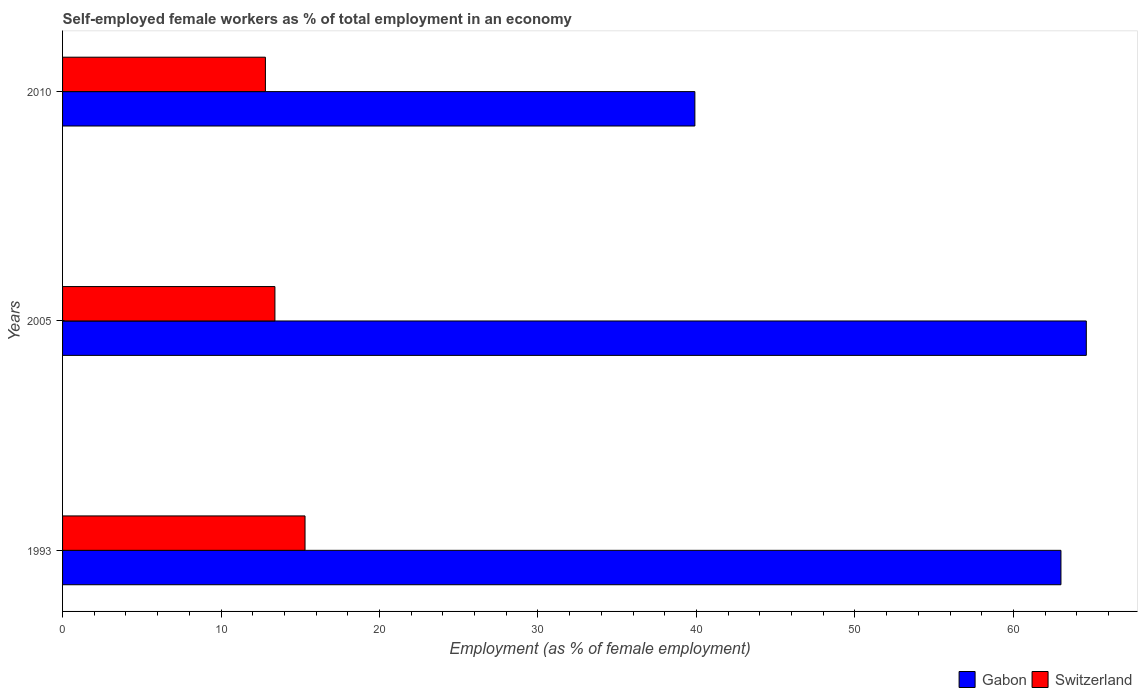How many different coloured bars are there?
Offer a very short reply. 2. How many groups of bars are there?
Provide a succinct answer. 3. Are the number of bars per tick equal to the number of legend labels?
Offer a terse response. Yes. What is the percentage of self-employed female workers in Switzerland in 1993?
Ensure brevity in your answer.  15.3. Across all years, what is the maximum percentage of self-employed female workers in Switzerland?
Keep it short and to the point. 15.3. Across all years, what is the minimum percentage of self-employed female workers in Gabon?
Make the answer very short. 39.9. In which year was the percentage of self-employed female workers in Gabon maximum?
Offer a terse response. 2005. In which year was the percentage of self-employed female workers in Gabon minimum?
Your answer should be compact. 2010. What is the total percentage of self-employed female workers in Gabon in the graph?
Provide a succinct answer. 167.5. What is the difference between the percentage of self-employed female workers in Switzerland in 1993 and that in 2005?
Your answer should be very brief. 1.9. What is the difference between the percentage of self-employed female workers in Gabon in 2010 and the percentage of self-employed female workers in Switzerland in 1993?
Give a very brief answer. 24.6. What is the average percentage of self-employed female workers in Gabon per year?
Your answer should be compact. 55.83. In the year 2010, what is the difference between the percentage of self-employed female workers in Switzerland and percentage of self-employed female workers in Gabon?
Provide a short and direct response. -27.1. What is the ratio of the percentage of self-employed female workers in Switzerland in 1993 to that in 2005?
Provide a succinct answer. 1.14. Is the percentage of self-employed female workers in Switzerland in 1993 less than that in 2010?
Ensure brevity in your answer.  No. Is the difference between the percentage of self-employed female workers in Switzerland in 1993 and 2005 greater than the difference between the percentage of self-employed female workers in Gabon in 1993 and 2005?
Offer a terse response. Yes. What is the difference between the highest and the second highest percentage of self-employed female workers in Switzerland?
Offer a very short reply. 1.9. In how many years, is the percentage of self-employed female workers in Switzerland greater than the average percentage of self-employed female workers in Switzerland taken over all years?
Provide a short and direct response. 1. What does the 1st bar from the top in 2010 represents?
Give a very brief answer. Switzerland. What does the 2nd bar from the bottom in 2005 represents?
Provide a short and direct response. Switzerland. Are all the bars in the graph horizontal?
Make the answer very short. Yes. How many years are there in the graph?
Offer a terse response. 3. What is the difference between two consecutive major ticks on the X-axis?
Your answer should be compact. 10. Are the values on the major ticks of X-axis written in scientific E-notation?
Your answer should be compact. No. Does the graph contain any zero values?
Your answer should be compact. No. Does the graph contain grids?
Keep it short and to the point. No. How many legend labels are there?
Provide a succinct answer. 2. What is the title of the graph?
Your response must be concise. Self-employed female workers as % of total employment in an economy. What is the label or title of the X-axis?
Your answer should be very brief. Employment (as % of female employment). What is the label or title of the Y-axis?
Offer a terse response. Years. What is the Employment (as % of female employment) in Switzerland in 1993?
Your answer should be very brief. 15.3. What is the Employment (as % of female employment) in Gabon in 2005?
Your answer should be very brief. 64.6. What is the Employment (as % of female employment) of Switzerland in 2005?
Keep it short and to the point. 13.4. What is the Employment (as % of female employment) in Gabon in 2010?
Make the answer very short. 39.9. What is the Employment (as % of female employment) in Switzerland in 2010?
Offer a terse response. 12.8. Across all years, what is the maximum Employment (as % of female employment) of Gabon?
Offer a very short reply. 64.6. Across all years, what is the maximum Employment (as % of female employment) of Switzerland?
Offer a very short reply. 15.3. Across all years, what is the minimum Employment (as % of female employment) in Gabon?
Give a very brief answer. 39.9. Across all years, what is the minimum Employment (as % of female employment) in Switzerland?
Make the answer very short. 12.8. What is the total Employment (as % of female employment) of Gabon in the graph?
Your answer should be compact. 167.5. What is the total Employment (as % of female employment) in Switzerland in the graph?
Your response must be concise. 41.5. What is the difference between the Employment (as % of female employment) in Gabon in 1993 and that in 2005?
Your response must be concise. -1.6. What is the difference between the Employment (as % of female employment) of Switzerland in 1993 and that in 2005?
Your answer should be compact. 1.9. What is the difference between the Employment (as % of female employment) of Gabon in 1993 and that in 2010?
Give a very brief answer. 23.1. What is the difference between the Employment (as % of female employment) in Gabon in 2005 and that in 2010?
Provide a short and direct response. 24.7. What is the difference between the Employment (as % of female employment) in Switzerland in 2005 and that in 2010?
Your answer should be compact. 0.6. What is the difference between the Employment (as % of female employment) of Gabon in 1993 and the Employment (as % of female employment) of Switzerland in 2005?
Make the answer very short. 49.6. What is the difference between the Employment (as % of female employment) of Gabon in 1993 and the Employment (as % of female employment) of Switzerland in 2010?
Make the answer very short. 50.2. What is the difference between the Employment (as % of female employment) in Gabon in 2005 and the Employment (as % of female employment) in Switzerland in 2010?
Your answer should be very brief. 51.8. What is the average Employment (as % of female employment) in Gabon per year?
Your answer should be compact. 55.83. What is the average Employment (as % of female employment) of Switzerland per year?
Provide a short and direct response. 13.83. In the year 1993, what is the difference between the Employment (as % of female employment) of Gabon and Employment (as % of female employment) of Switzerland?
Give a very brief answer. 47.7. In the year 2005, what is the difference between the Employment (as % of female employment) of Gabon and Employment (as % of female employment) of Switzerland?
Offer a very short reply. 51.2. In the year 2010, what is the difference between the Employment (as % of female employment) of Gabon and Employment (as % of female employment) of Switzerland?
Provide a short and direct response. 27.1. What is the ratio of the Employment (as % of female employment) in Gabon in 1993 to that in 2005?
Give a very brief answer. 0.98. What is the ratio of the Employment (as % of female employment) in Switzerland in 1993 to that in 2005?
Offer a terse response. 1.14. What is the ratio of the Employment (as % of female employment) in Gabon in 1993 to that in 2010?
Keep it short and to the point. 1.58. What is the ratio of the Employment (as % of female employment) in Switzerland in 1993 to that in 2010?
Your answer should be very brief. 1.2. What is the ratio of the Employment (as % of female employment) in Gabon in 2005 to that in 2010?
Your answer should be very brief. 1.62. What is the ratio of the Employment (as % of female employment) in Switzerland in 2005 to that in 2010?
Provide a succinct answer. 1.05. What is the difference between the highest and the lowest Employment (as % of female employment) in Gabon?
Your answer should be compact. 24.7. What is the difference between the highest and the lowest Employment (as % of female employment) in Switzerland?
Make the answer very short. 2.5. 